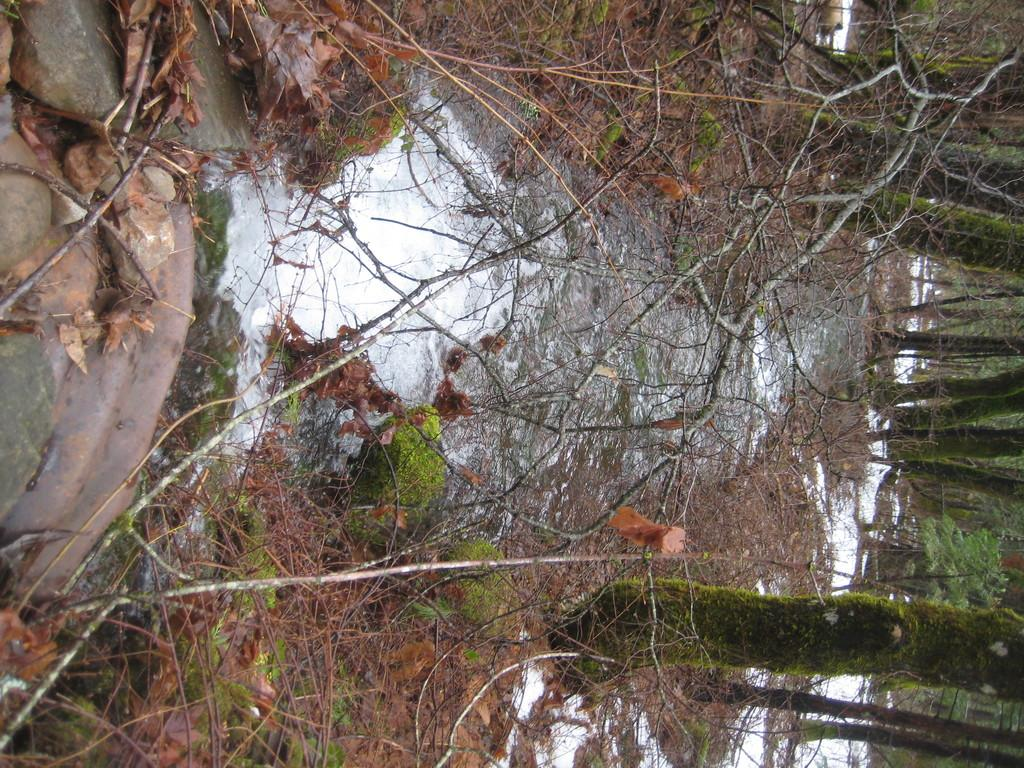What type of vegetation can be seen in the image? There are trees in the image. What is the weather condition in the image? There is snow in the image, indicating a cold climate. What can be found on the ground in the image? There are shredded leaves and rocks visible in the image. What natural element is present in the image? There is water visible in the image. What type of feather can be seen hanging from the curtain in the image? There is no curtain or feather present in the image; it features trees, snow, shredded leaves, rocks, and water. How many girls are visible in the image? There are no girls present in the image. 